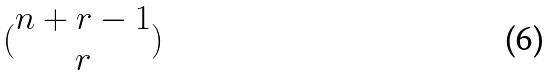Convert formula to latex. <formula><loc_0><loc_0><loc_500><loc_500>( \begin{matrix} n + r - 1 \\ r \end{matrix} )</formula> 